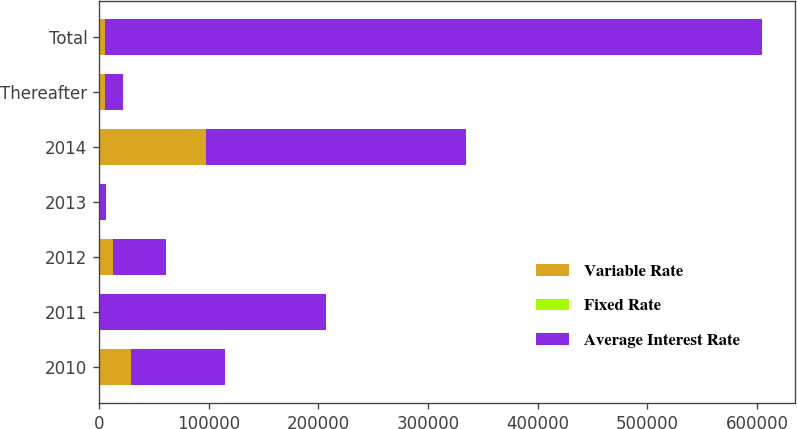Convert chart. <chart><loc_0><loc_0><loc_500><loc_500><stacked_bar_chart><ecel><fcel>2010<fcel>2011<fcel>2012<fcel>2013<fcel>2014<fcel>Thereafter<fcel>Total<nl><fcel>Variable Rate<fcel>29410<fcel>405<fcel>12870<fcel>1182<fcel>97334<fcel>5502<fcel>5502<nl><fcel>Fixed Rate<fcel>4.49<fcel>4.46<fcel>4.45<fcel>4.45<fcel>4.42<fcel>3.88<fcel>4.31<nl><fcel>Average Interest Rate<fcel>85720<fcel>206546<fcel>47889<fcel>5502<fcel>237166<fcel>16000<fcel>598823<nl></chart> 